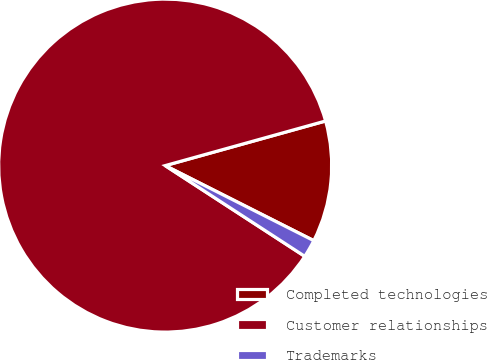Convert chart to OTSL. <chart><loc_0><loc_0><loc_500><loc_500><pie_chart><fcel>Completed technologies<fcel>Customer relationships<fcel>Trademarks<nl><fcel>11.76%<fcel>86.51%<fcel>1.73%<nl></chart> 